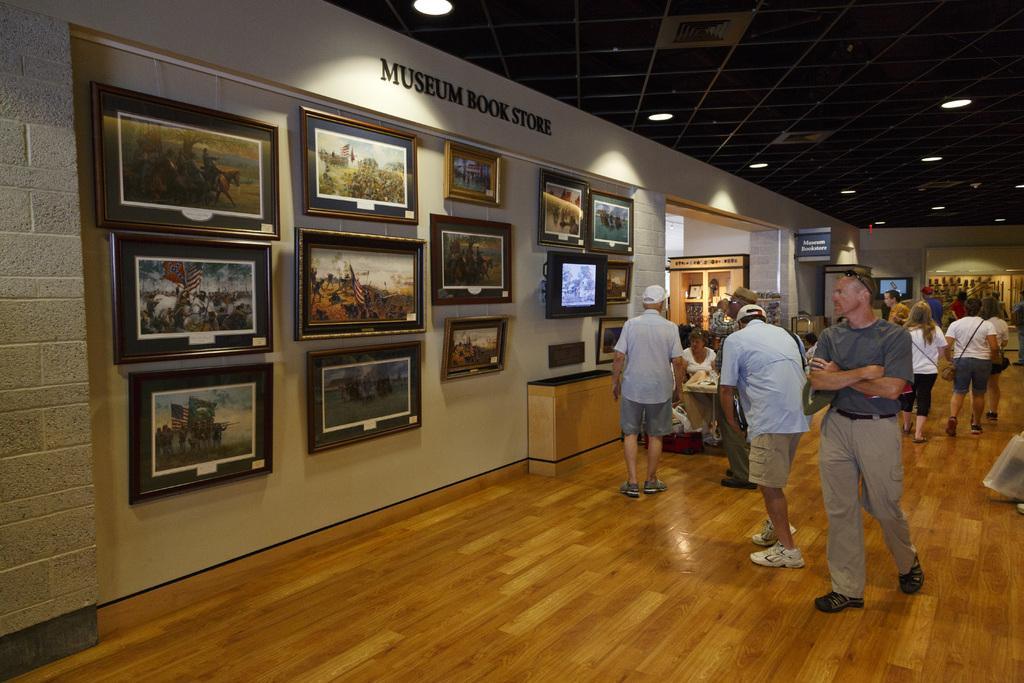Please provide a concise description of this image. In this image I can see a museum book store and on the left there are some painting on the wall and there are many people on the right. 